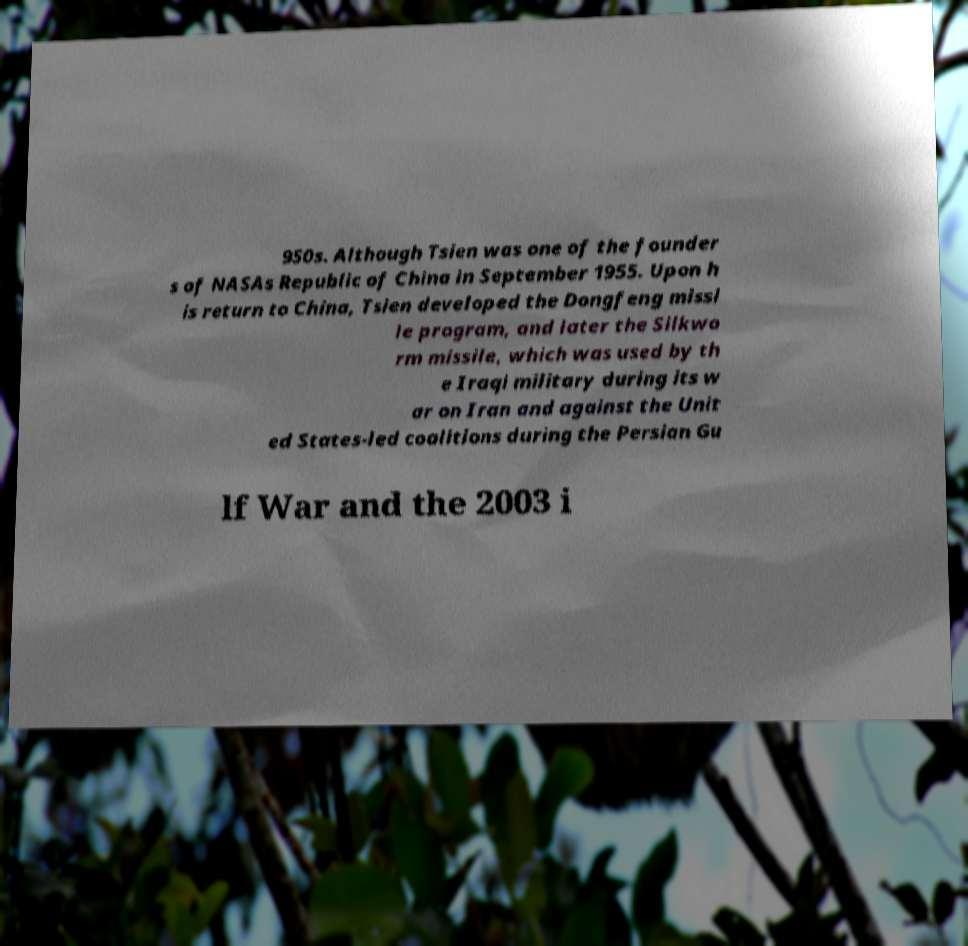Can you accurately transcribe the text from the provided image for me? 950s. Although Tsien was one of the founder s of NASAs Republic of China in September 1955. Upon h is return to China, Tsien developed the Dongfeng missi le program, and later the Silkwo rm missile, which was used by th e Iraqi military during its w ar on Iran and against the Unit ed States-led coalitions during the Persian Gu lf War and the 2003 i 